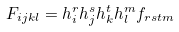<formula> <loc_0><loc_0><loc_500><loc_500>F _ { i j k l } = h _ { i } ^ { r } h _ { j } ^ { s } h _ { k } ^ { t } h _ { l } ^ { m } f _ { r s t m }</formula> 